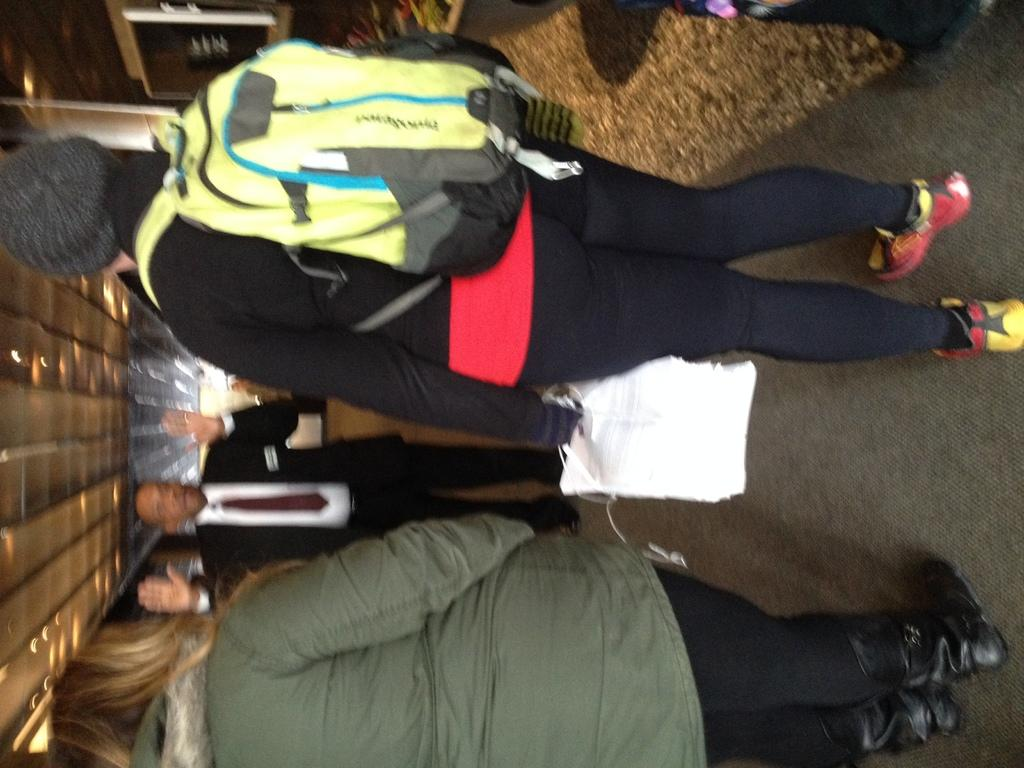How many people are present in the image? There are four persons in the image. Can you describe any specific items that one of the persons is carrying? One person is wearing a backpack. What is the person with the backpack holding in their hand? The person with the backpack is holding an object in their hand. How many lamps are attached to the roof in the image? There are fewer lamps attached to the roof in the image. What type of wood is the crook using to walk in the image? There is no crook or walking stick present in the image, and therefore no such activity can be observed. 